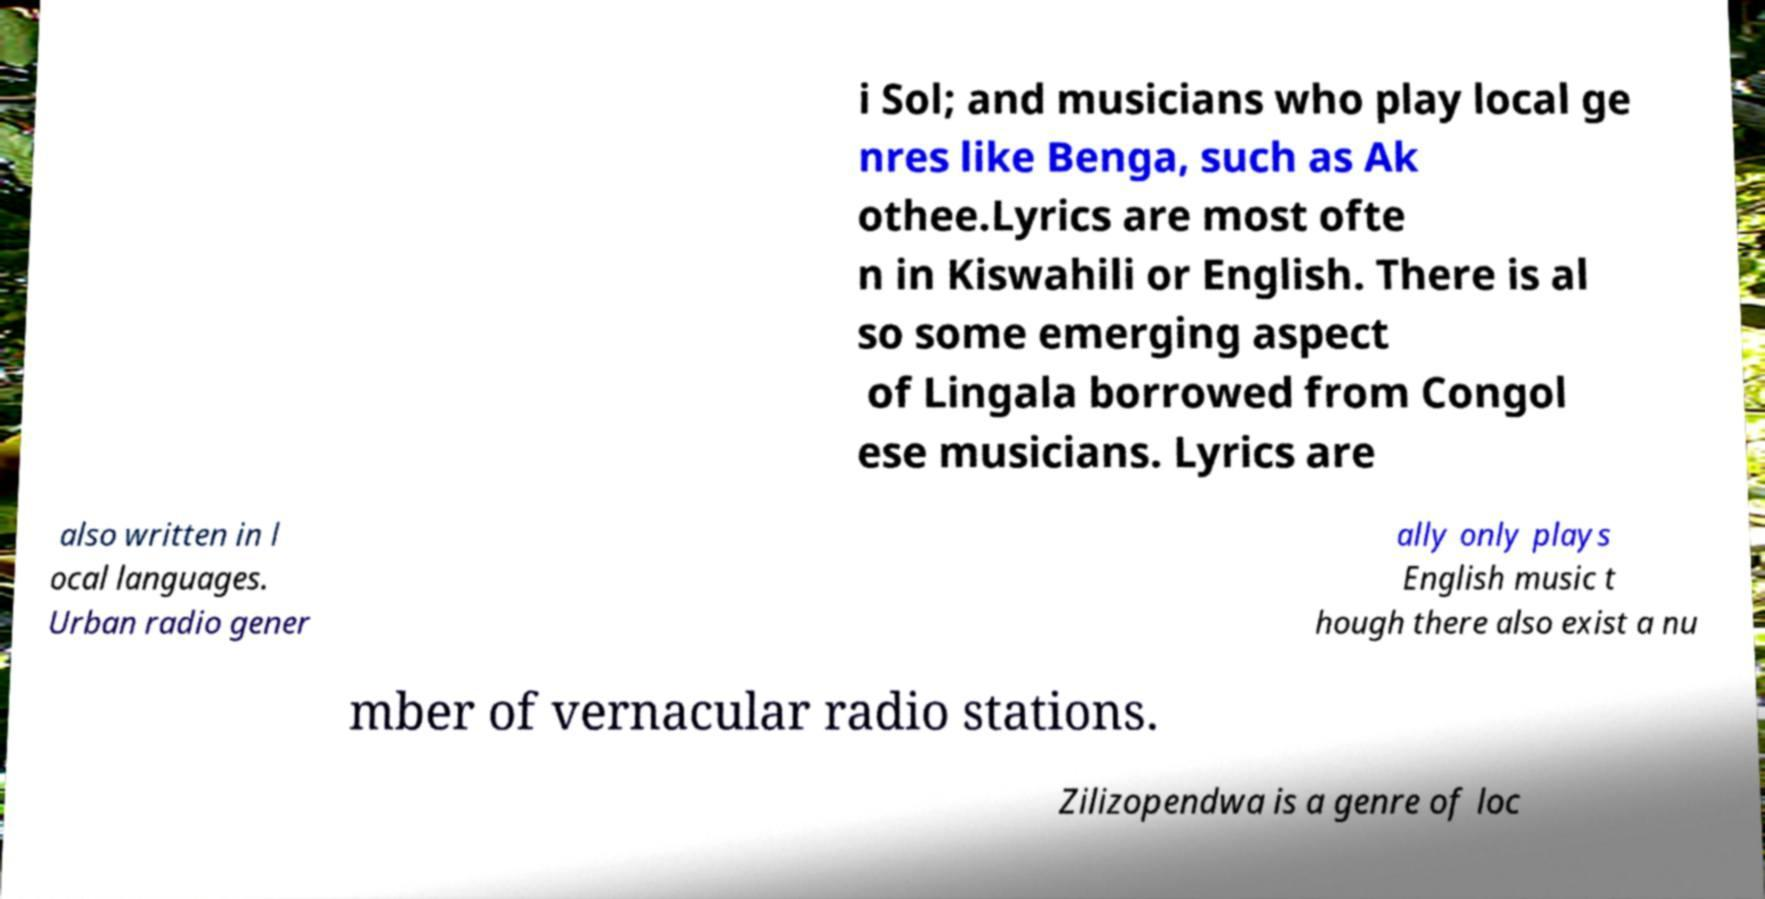Could you assist in decoding the text presented in this image and type it out clearly? i Sol; and musicians who play local ge nres like Benga, such as Ak othee.Lyrics are most ofte n in Kiswahili or English. There is al so some emerging aspect of Lingala borrowed from Congol ese musicians. Lyrics are also written in l ocal languages. Urban radio gener ally only plays English music t hough there also exist a nu mber of vernacular radio stations. Zilizopendwa is a genre of loc 